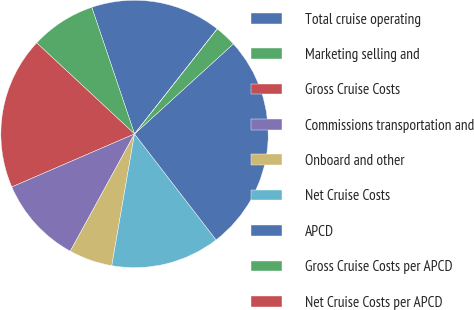Convert chart to OTSL. <chart><loc_0><loc_0><loc_500><loc_500><pie_chart><fcel>Total cruise operating<fcel>Marketing selling and<fcel>Gross Cruise Costs<fcel>Commissions transportation and<fcel>Onboard and other<fcel>Net Cruise Costs<fcel>APCD<fcel>Gross Cruise Costs per APCD<fcel>Net Cruise Costs per APCD<nl><fcel>15.79%<fcel>7.89%<fcel>18.42%<fcel>10.53%<fcel>5.26%<fcel>13.16%<fcel>26.32%<fcel>2.63%<fcel>0.0%<nl></chart> 